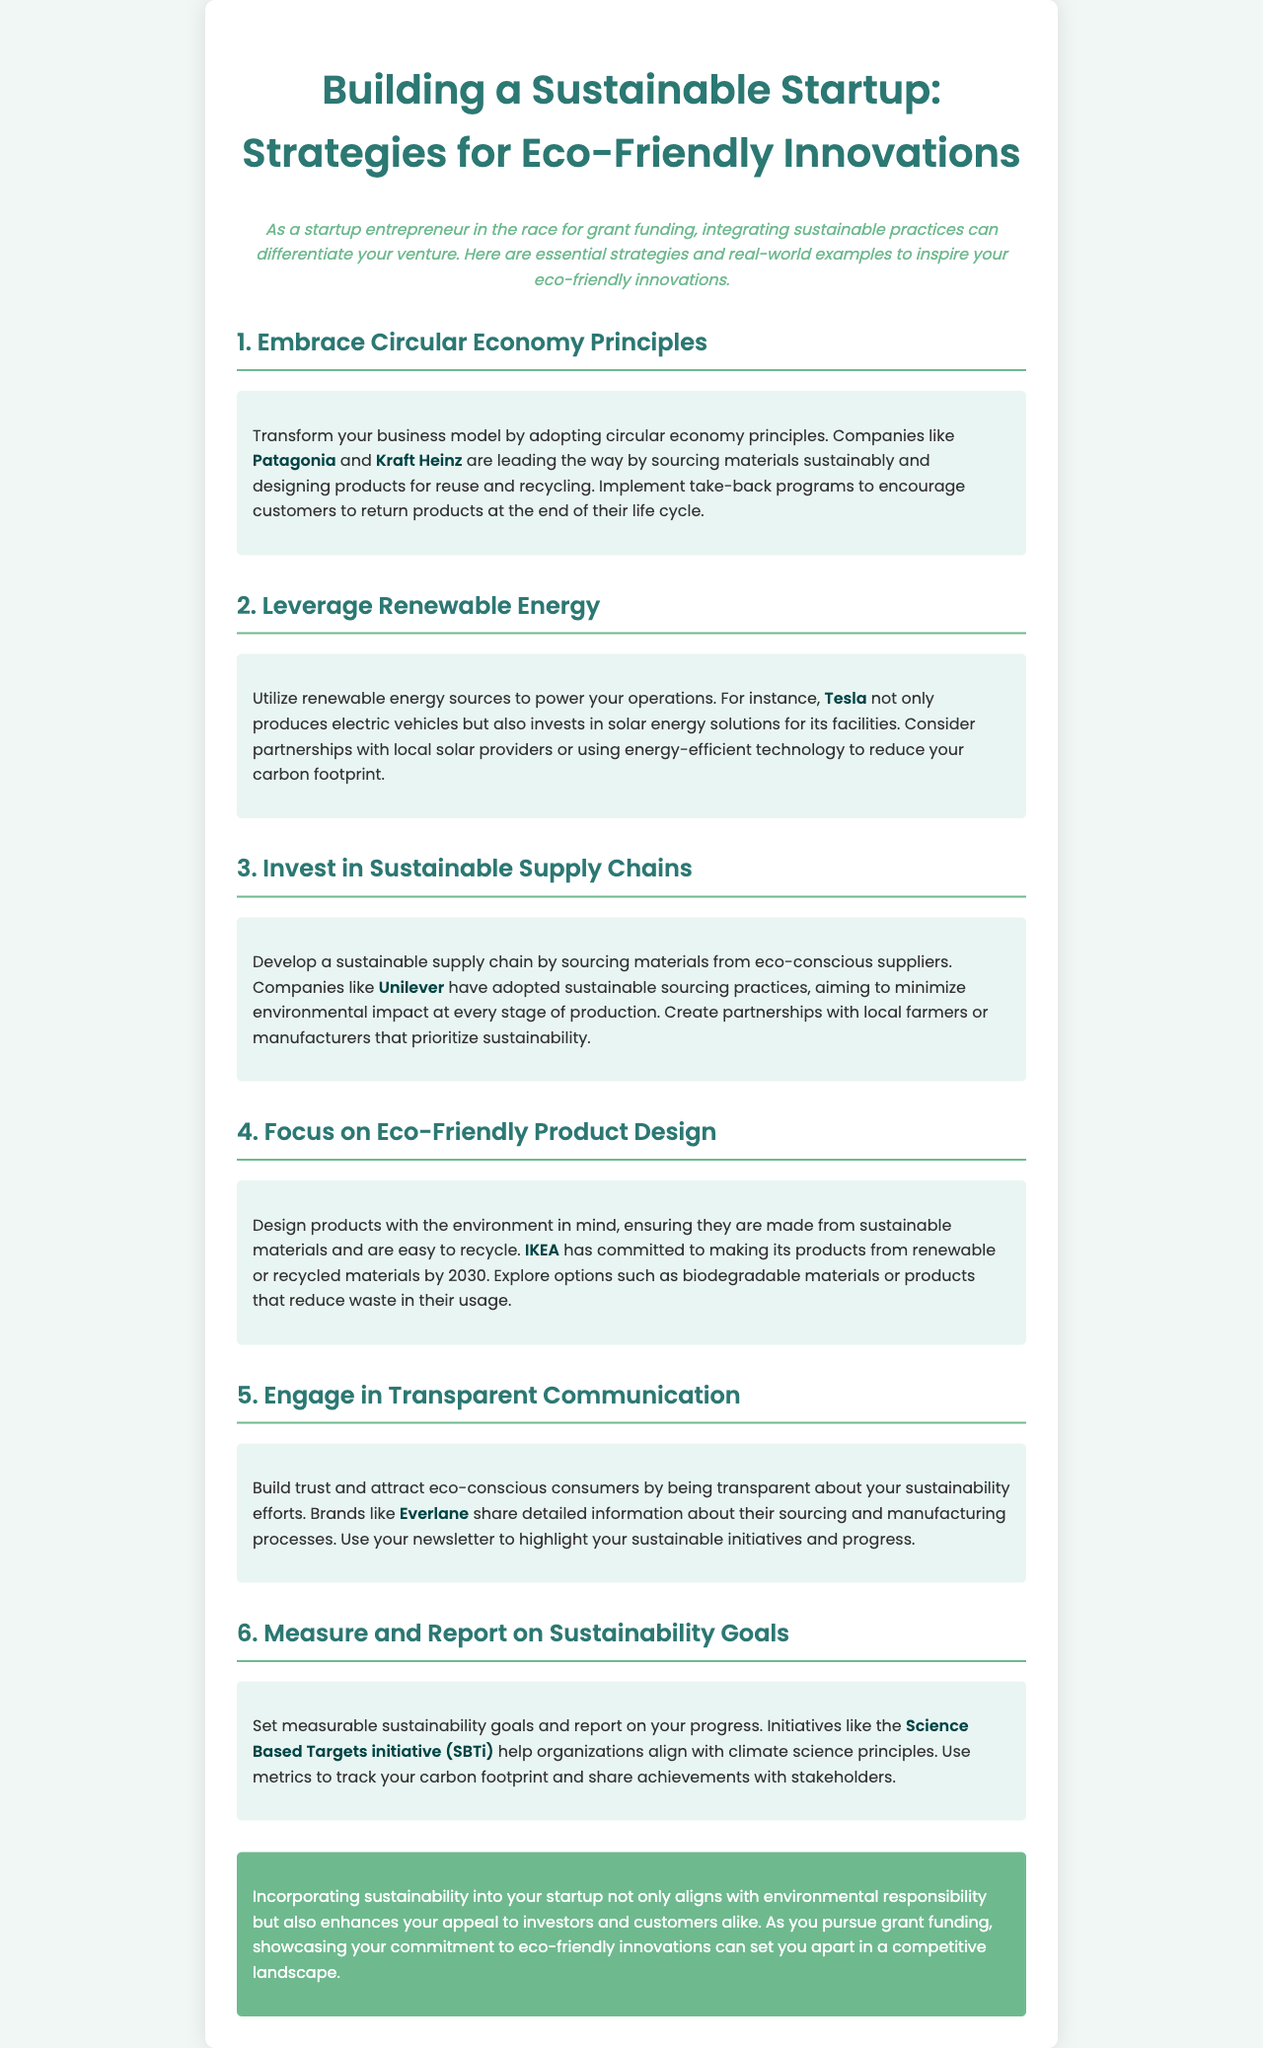what is the title of the newsletter? The title of the newsletter is stated in the header section, which clearly presents the main topic.
Answer: Building a Sustainable Startup: Strategies for Eco-Friendly Innovations who are the companies mentioned in the first strategy? The first strategy mentions two companies leading in sustainable practices, demonstrating real-world examples.
Answer: Patagonia and Kraft Heinz which renewable energy solution does Tesla invest in? The newsletter specifies Tesla's investment in solar energy solutions as part of their sustainability efforts.
Answer: solar energy what commitment has IKEA made regarding product materials? The document details IKEA's commitment about the types of materials they will use for their products in the future.
Answer: renewable or recycled materials by 2030 which initiative helps organizations align with climate science? The newsletter references a specific initiative aimed at helping organizations with sustainability goals and climate principles.
Answer: Science Based Targets initiative (SBTi) how does Everlane enhance trust with consumers? The document explains Everlane's approach to building trust through transparent practices regarding their business operations.
Answer: transparent communication what is a key benefit of incorporating sustainability into a startup? The conclusion emphasizes an advantage of adopting sustainable practices within a startup, particularly in relation to external perceptions.
Answer: enhances appeal to investors and customers 